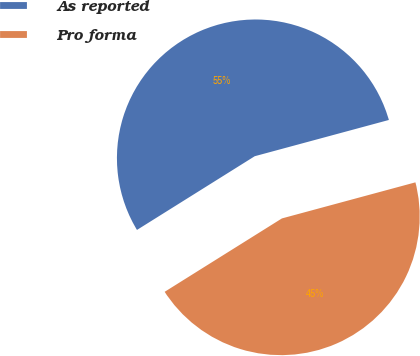Convert chart to OTSL. <chart><loc_0><loc_0><loc_500><loc_500><pie_chart><fcel>As reported<fcel>Pro forma<nl><fcel>54.7%<fcel>45.3%<nl></chart> 